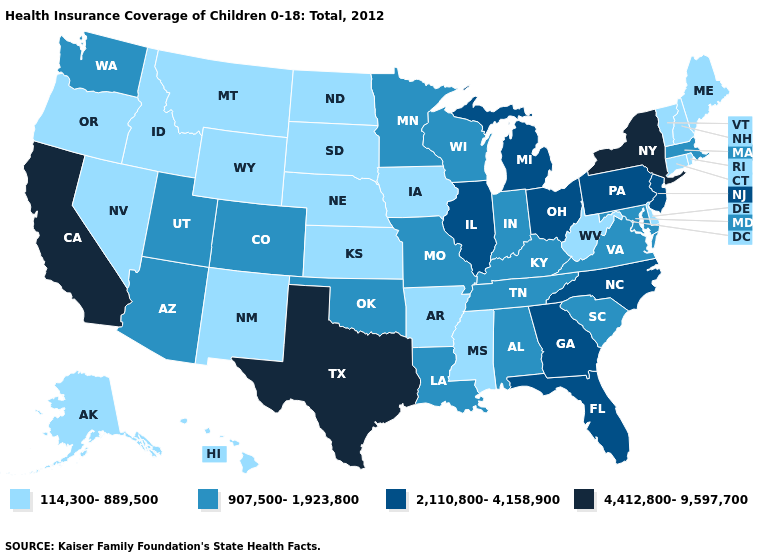What is the lowest value in states that border Connecticut?
Keep it brief. 114,300-889,500. Name the states that have a value in the range 4,412,800-9,597,700?
Concise answer only. California, New York, Texas. How many symbols are there in the legend?
Write a very short answer. 4. What is the value of New Hampshire?
Answer briefly. 114,300-889,500. What is the lowest value in states that border Delaware?
Keep it brief. 907,500-1,923,800. Does Massachusetts have the highest value in the Northeast?
Be succinct. No. Does Delaware have the same value as Ohio?
Concise answer only. No. Name the states that have a value in the range 2,110,800-4,158,900?
Short answer required. Florida, Georgia, Illinois, Michigan, New Jersey, North Carolina, Ohio, Pennsylvania. Name the states that have a value in the range 907,500-1,923,800?
Answer briefly. Alabama, Arizona, Colorado, Indiana, Kentucky, Louisiana, Maryland, Massachusetts, Minnesota, Missouri, Oklahoma, South Carolina, Tennessee, Utah, Virginia, Washington, Wisconsin. What is the lowest value in states that border Nebraska?
Be succinct. 114,300-889,500. What is the lowest value in the USA?
Be succinct. 114,300-889,500. Does New York have the highest value in the Northeast?
Answer briefly. Yes. 